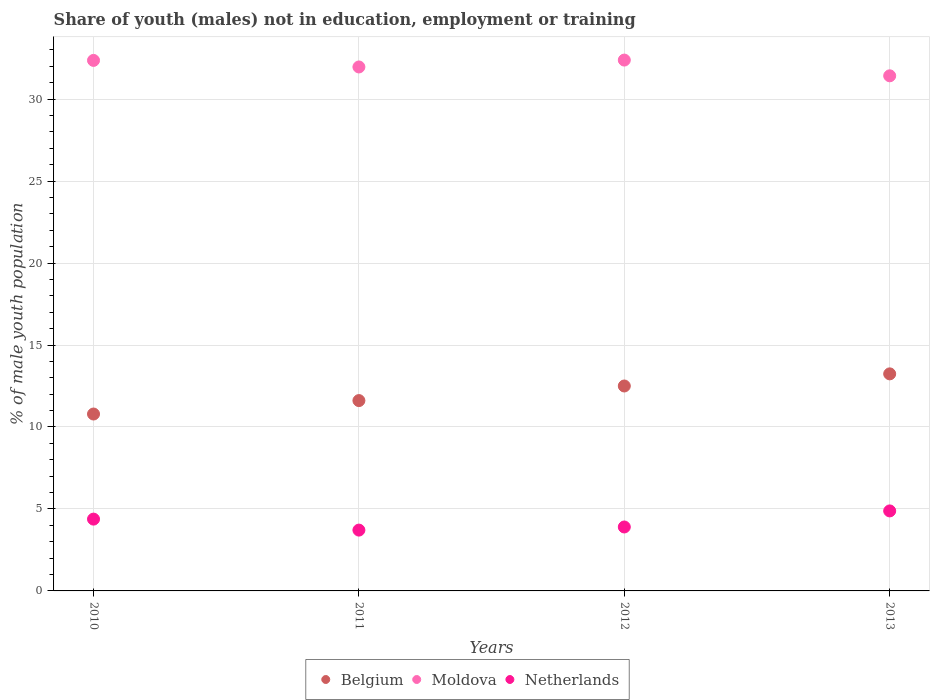Is the number of dotlines equal to the number of legend labels?
Provide a short and direct response. Yes. What is the percentage of unemployed males population in in Belgium in 2010?
Keep it short and to the point. 10.79. Across all years, what is the maximum percentage of unemployed males population in in Belgium?
Provide a short and direct response. 13.24. Across all years, what is the minimum percentage of unemployed males population in in Belgium?
Give a very brief answer. 10.79. What is the total percentage of unemployed males population in in Moldova in the graph?
Your answer should be very brief. 128.12. What is the difference between the percentage of unemployed males population in in Moldova in 2011 and that in 2013?
Give a very brief answer. 0.54. What is the difference between the percentage of unemployed males population in in Belgium in 2011 and the percentage of unemployed males population in in Moldova in 2010?
Your response must be concise. -20.75. What is the average percentage of unemployed males population in in Moldova per year?
Your answer should be very brief. 32.03. In the year 2012, what is the difference between the percentage of unemployed males population in in Netherlands and percentage of unemployed males population in in Moldova?
Give a very brief answer. -28.48. In how many years, is the percentage of unemployed males population in in Moldova greater than 28 %?
Your response must be concise. 4. What is the ratio of the percentage of unemployed males population in in Belgium in 2010 to that in 2012?
Provide a succinct answer. 0.86. Is the percentage of unemployed males population in in Netherlands in 2011 less than that in 2013?
Keep it short and to the point. Yes. What is the difference between the highest and the second highest percentage of unemployed males population in in Belgium?
Your answer should be very brief. 0.74. What is the difference between the highest and the lowest percentage of unemployed males population in in Netherlands?
Give a very brief answer. 1.17. In how many years, is the percentage of unemployed males population in in Moldova greater than the average percentage of unemployed males population in in Moldova taken over all years?
Offer a very short reply. 2. Is the sum of the percentage of unemployed males population in in Moldova in 2010 and 2012 greater than the maximum percentage of unemployed males population in in Belgium across all years?
Offer a very short reply. Yes. Is it the case that in every year, the sum of the percentage of unemployed males population in in Moldova and percentage of unemployed males population in in Netherlands  is greater than the percentage of unemployed males population in in Belgium?
Your response must be concise. Yes. Is the percentage of unemployed males population in in Netherlands strictly greater than the percentage of unemployed males population in in Moldova over the years?
Your answer should be very brief. No. How many years are there in the graph?
Offer a very short reply. 4. Are the values on the major ticks of Y-axis written in scientific E-notation?
Provide a short and direct response. No. Does the graph contain any zero values?
Make the answer very short. No. Does the graph contain grids?
Your answer should be compact. Yes. Where does the legend appear in the graph?
Offer a very short reply. Bottom center. How many legend labels are there?
Make the answer very short. 3. What is the title of the graph?
Keep it short and to the point. Share of youth (males) not in education, employment or training. Does "Armenia" appear as one of the legend labels in the graph?
Provide a succinct answer. No. What is the label or title of the X-axis?
Provide a succinct answer. Years. What is the label or title of the Y-axis?
Your answer should be compact. % of male youth population. What is the % of male youth population in Belgium in 2010?
Your answer should be compact. 10.79. What is the % of male youth population of Moldova in 2010?
Provide a short and direct response. 32.36. What is the % of male youth population of Netherlands in 2010?
Your response must be concise. 4.38. What is the % of male youth population of Belgium in 2011?
Give a very brief answer. 11.61. What is the % of male youth population of Moldova in 2011?
Give a very brief answer. 31.96. What is the % of male youth population of Netherlands in 2011?
Offer a terse response. 3.71. What is the % of male youth population in Moldova in 2012?
Make the answer very short. 32.38. What is the % of male youth population of Netherlands in 2012?
Provide a short and direct response. 3.9. What is the % of male youth population in Belgium in 2013?
Your answer should be very brief. 13.24. What is the % of male youth population of Moldova in 2013?
Offer a terse response. 31.42. What is the % of male youth population of Netherlands in 2013?
Make the answer very short. 4.88. Across all years, what is the maximum % of male youth population in Belgium?
Your answer should be very brief. 13.24. Across all years, what is the maximum % of male youth population in Moldova?
Offer a very short reply. 32.38. Across all years, what is the maximum % of male youth population of Netherlands?
Your answer should be compact. 4.88. Across all years, what is the minimum % of male youth population of Belgium?
Provide a short and direct response. 10.79. Across all years, what is the minimum % of male youth population of Moldova?
Provide a short and direct response. 31.42. Across all years, what is the minimum % of male youth population of Netherlands?
Give a very brief answer. 3.71. What is the total % of male youth population of Belgium in the graph?
Provide a short and direct response. 48.14. What is the total % of male youth population of Moldova in the graph?
Provide a succinct answer. 128.12. What is the total % of male youth population in Netherlands in the graph?
Your answer should be very brief. 16.87. What is the difference between the % of male youth population of Belgium in 2010 and that in 2011?
Provide a succinct answer. -0.82. What is the difference between the % of male youth population in Moldova in 2010 and that in 2011?
Offer a very short reply. 0.4. What is the difference between the % of male youth population in Netherlands in 2010 and that in 2011?
Your answer should be compact. 0.67. What is the difference between the % of male youth population of Belgium in 2010 and that in 2012?
Keep it short and to the point. -1.71. What is the difference between the % of male youth population of Moldova in 2010 and that in 2012?
Keep it short and to the point. -0.02. What is the difference between the % of male youth population in Netherlands in 2010 and that in 2012?
Provide a succinct answer. 0.48. What is the difference between the % of male youth population in Belgium in 2010 and that in 2013?
Your answer should be very brief. -2.45. What is the difference between the % of male youth population in Moldova in 2010 and that in 2013?
Your response must be concise. 0.94. What is the difference between the % of male youth population in Belgium in 2011 and that in 2012?
Provide a succinct answer. -0.89. What is the difference between the % of male youth population of Moldova in 2011 and that in 2012?
Make the answer very short. -0.42. What is the difference between the % of male youth population of Netherlands in 2011 and that in 2012?
Provide a short and direct response. -0.19. What is the difference between the % of male youth population in Belgium in 2011 and that in 2013?
Make the answer very short. -1.63. What is the difference between the % of male youth population of Moldova in 2011 and that in 2013?
Give a very brief answer. 0.54. What is the difference between the % of male youth population in Netherlands in 2011 and that in 2013?
Your response must be concise. -1.17. What is the difference between the % of male youth population of Belgium in 2012 and that in 2013?
Keep it short and to the point. -0.74. What is the difference between the % of male youth population in Moldova in 2012 and that in 2013?
Provide a succinct answer. 0.96. What is the difference between the % of male youth population in Netherlands in 2012 and that in 2013?
Your answer should be very brief. -0.98. What is the difference between the % of male youth population in Belgium in 2010 and the % of male youth population in Moldova in 2011?
Keep it short and to the point. -21.17. What is the difference between the % of male youth population in Belgium in 2010 and the % of male youth population in Netherlands in 2011?
Keep it short and to the point. 7.08. What is the difference between the % of male youth population of Moldova in 2010 and the % of male youth population of Netherlands in 2011?
Your answer should be very brief. 28.65. What is the difference between the % of male youth population in Belgium in 2010 and the % of male youth population in Moldova in 2012?
Your answer should be compact. -21.59. What is the difference between the % of male youth population of Belgium in 2010 and the % of male youth population of Netherlands in 2012?
Your response must be concise. 6.89. What is the difference between the % of male youth population in Moldova in 2010 and the % of male youth population in Netherlands in 2012?
Make the answer very short. 28.46. What is the difference between the % of male youth population of Belgium in 2010 and the % of male youth population of Moldova in 2013?
Provide a short and direct response. -20.63. What is the difference between the % of male youth population in Belgium in 2010 and the % of male youth population in Netherlands in 2013?
Keep it short and to the point. 5.91. What is the difference between the % of male youth population of Moldova in 2010 and the % of male youth population of Netherlands in 2013?
Keep it short and to the point. 27.48. What is the difference between the % of male youth population in Belgium in 2011 and the % of male youth population in Moldova in 2012?
Offer a terse response. -20.77. What is the difference between the % of male youth population in Belgium in 2011 and the % of male youth population in Netherlands in 2012?
Offer a terse response. 7.71. What is the difference between the % of male youth population of Moldova in 2011 and the % of male youth population of Netherlands in 2012?
Give a very brief answer. 28.06. What is the difference between the % of male youth population in Belgium in 2011 and the % of male youth population in Moldova in 2013?
Your answer should be compact. -19.81. What is the difference between the % of male youth population of Belgium in 2011 and the % of male youth population of Netherlands in 2013?
Give a very brief answer. 6.73. What is the difference between the % of male youth population of Moldova in 2011 and the % of male youth population of Netherlands in 2013?
Offer a terse response. 27.08. What is the difference between the % of male youth population in Belgium in 2012 and the % of male youth population in Moldova in 2013?
Your response must be concise. -18.92. What is the difference between the % of male youth population of Belgium in 2012 and the % of male youth population of Netherlands in 2013?
Keep it short and to the point. 7.62. What is the average % of male youth population of Belgium per year?
Offer a very short reply. 12.04. What is the average % of male youth population in Moldova per year?
Make the answer very short. 32.03. What is the average % of male youth population of Netherlands per year?
Offer a terse response. 4.22. In the year 2010, what is the difference between the % of male youth population of Belgium and % of male youth population of Moldova?
Keep it short and to the point. -21.57. In the year 2010, what is the difference between the % of male youth population in Belgium and % of male youth population in Netherlands?
Your answer should be compact. 6.41. In the year 2010, what is the difference between the % of male youth population in Moldova and % of male youth population in Netherlands?
Give a very brief answer. 27.98. In the year 2011, what is the difference between the % of male youth population of Belgium and % of male youth population of Moldova?
Offer a very short reply. -20.35. In the year 2011, what is the difference between the % of male youth population of Moldova and % of male youth population of Netherlands?
Your answer should be very brief. 28.25. In the year 2012, what is the difference between the % of male youth population of Belgium and % of male youth population of Moldova?
Your answer should be compact. -19.88. In the year 2012, what is the difference between the % of male youth population of Belgium and % of male youth population of Netherlands?
Give a very brief answer. 8.6. In the year 2012, what is the difference between the % of male youth population in Moldova and % of male youth population in Netherlands?
Offer a very short reply. 28.48. In the year 2013, what is the difference between the % of male youth population of Belgium and % of male youth population of Moldova?
Provide a short and direct response. -18.18. In the year 2013, what is the difference between the % of male youth population in Belgium and % of male youth population in Netherlands?
Ensure brevity in your answer.  8.36. In the year 2013, what is the difference between the % of male youth population in Moldova and % of male youth population in Netherlands?
Ensure brevity in your answer.  26.54. What is the ratio of the % of male youth population of Belgium in 2010 to that in 2011?
Offer a terse response. 0.93. What is the ratio of the % of male youth population in Moldova in 2010 to that in 2011?
Your answer should be very brief. 1.01. What is the ratio of the % of male youth population of Netherlands in 2010 to that in 2011?
Give a very brief answer. 1.18. What is the ratio of the % of male youth population in Belgium in 2010 to that in 2012?
Make the answer very short. 0.86. What is the ratio of the % of male youth population of Moldova in 2010 to that in 2012?
Provide a succinct answer. 1. What is the ratio of the % of male youth population in Netherlands in 2010 to that in 2012?
Give a very brief answer. 1.12. What is the ratio of the % of male youth population in Belgium in 2010 to that in 2013?
Your answer should be compact. 0.81. What is the ratio of the % of male youth population in Moldova in 2010 to that in 2013?
Your response must be concise. 1.03. What is the ratio of the % of male youth population of Netherlands in 2010 to that in 2013?
Your response must be concise. 0.9. What is the ratio of the % of male youth population in Belgium in 2011 to that in 2012?
Your response must be concise. 0.93. What is the ratio of the % of male youth population in Netherlands in 2011 to that in 2012?
Provide a short and direct response. 0.95. What is the ratio of the % of male youth population in Belgium in 2011 to that in 2013?
Ensure brevity in your answer.  0.88. What is the ratio of the % of male youth population of Moldova in 2011 to that in 2013?
Provide a succinct answer. 1.02. What is the ratio of the % of male youth population in Netherlands in 2011 to that in 2013?
Your response must be concise. 0.76. What is the ratio of the % of male youth population in Belgium in 2012 to that in 2013?
Make the answer very short. 0.94. What is the ratio of the % of male youth population in Moldova in 2012 to that in 2013?
Offer a terse response. 1.03. What is the ratio of the % of male youth population in Netherlands in 2012 to that in 2013?
Offer a terse response. 0.8. What is the difference between the highest and the second highest % of male youth population in Belgium?
Make the answer very short. 0.74. What is the difference between the highest and the second highest % of male youth population of Netherlands?
Your response must be concise. 0.5. What is the difference between the highest and the lowest % of male youth population of Belgium?
Provide a short and direct response. 2.45. What is the difference between the highest and the lowest % of male youth population in Netherlands?
Offer a terse response. 1.17. 